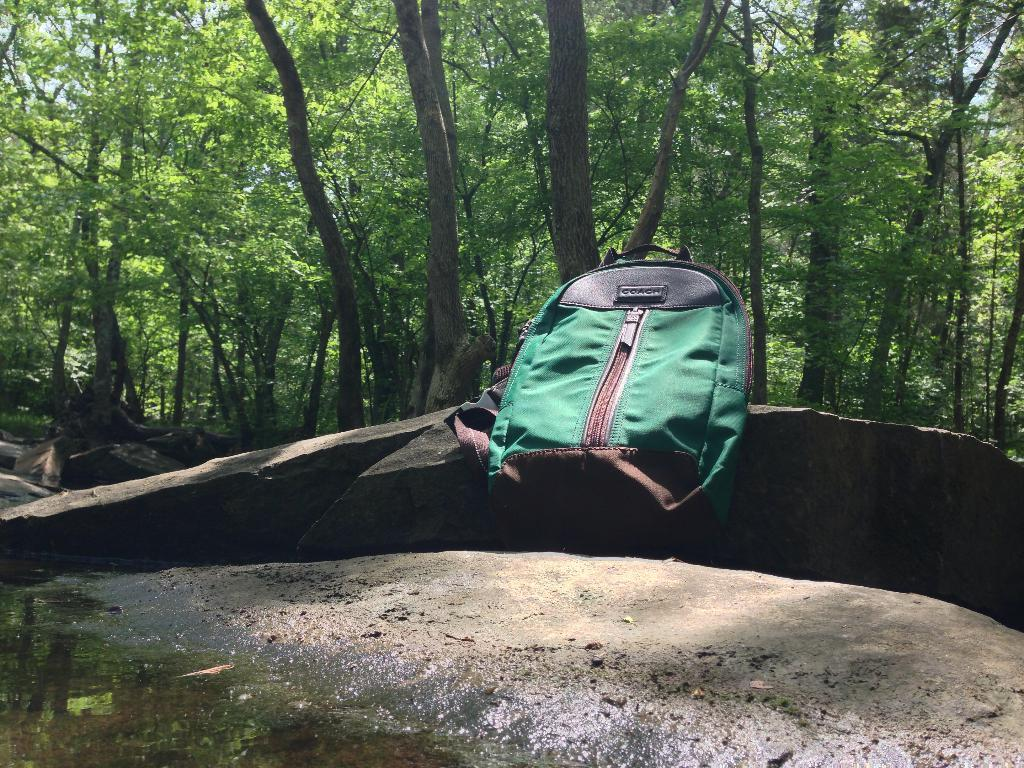What object can be seen in the image? There is a bag in the image. Where is the bag located? The bag is on a rock. What type of natural environment is visible in the image? There are trees visible in the image. How does the bag show respect to the environment in the image? The image does not provide information about the bag's impact on the environment or its respect for it. 